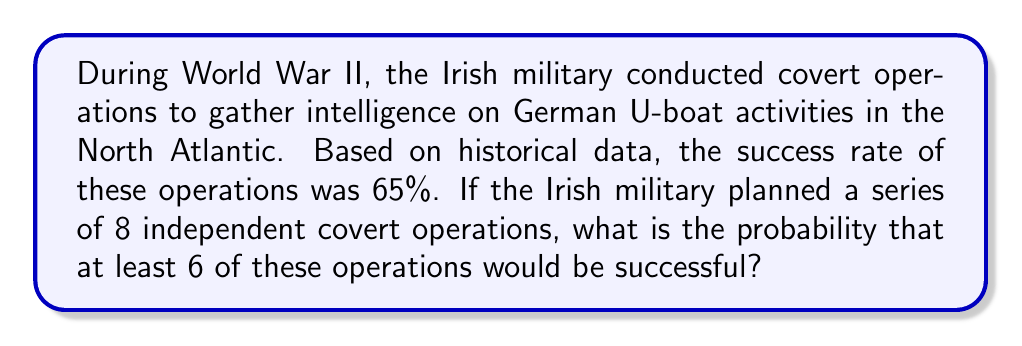Give your solution to this math problem. To solve this problem, we'll use the binomial probability distribution, as we're dealing with a fixed number of independent trials (operations) with two possible outcomes (success or failure) for each trial.

Let's define our variables:
$n = 8$ (total number of operations)
$p = 0.65$ (probability of success for each operation)
$q = 1 - p = 0.35$ (probability of failure for each operation)

We want to find the probability of at least 6 successes, which means we need to calculate the probability of 6, 7, or 8 successes and sum them up.

The binomial probability formula is:

$$P(X = k) = \binom{n}{k} p^k q^{n-k}$$

Where $\binom{n}{k}$ is the binomial coefficient, calculated as:

$$\binom{n}{k} = \frac{n!}{k!(n-k)!}$$

Let's calculate the probability for each case:

For 6 successes:
$$P(X = 6) = \binom{8}{6} (0.65)^6 (0.35)^2 = 28 \times 0.075418 \times 0.1225 = 0.2587$$

For 7 successes:
$$P(X = 7) = \binom{8}{7} (0.65)^7 (0.35)^1 = 8 \times 0.116027 \times 0.35 = 0.3249$$

For 8 successes:
$$P(X = 8) = \binom{8}{8} (0.65)^8 (0.35)^0 = 1 \times 0.178509 \times 1 = 0.1785$$

Now, we sum these probabilities:

$$P(X \geq 6) = P(X = 6) + P(X = 7) + P(X = 8)$$
$$P(X \geq 6) = 0.2587 + 0.3249 + 0.1785 = 0.7621$$

Therefore, the probability of at least 6 successful operations out of 8 is approximately 0.7621 or 76.21%.
Answer: 0.7621 or 76.21% 